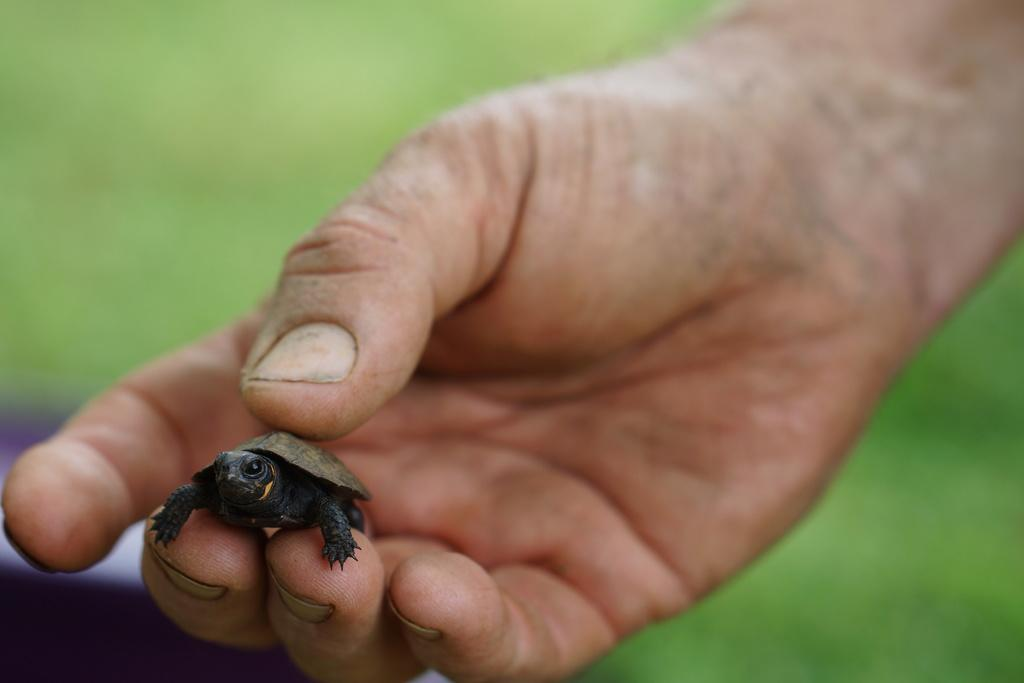Who or what is the main subject in the image? There is a person in the image. What is the person holding in the image? The person is holding a turtle. Can you describe the appearance of the turtle? The turtle is in black and grey color. How would you describe the background of the image? The background of the image is blurred. What type of nut can be seen shocking the turtle in the image? There is no nut present in the image, nor is there any indication of a shock being administered to the turtle. 